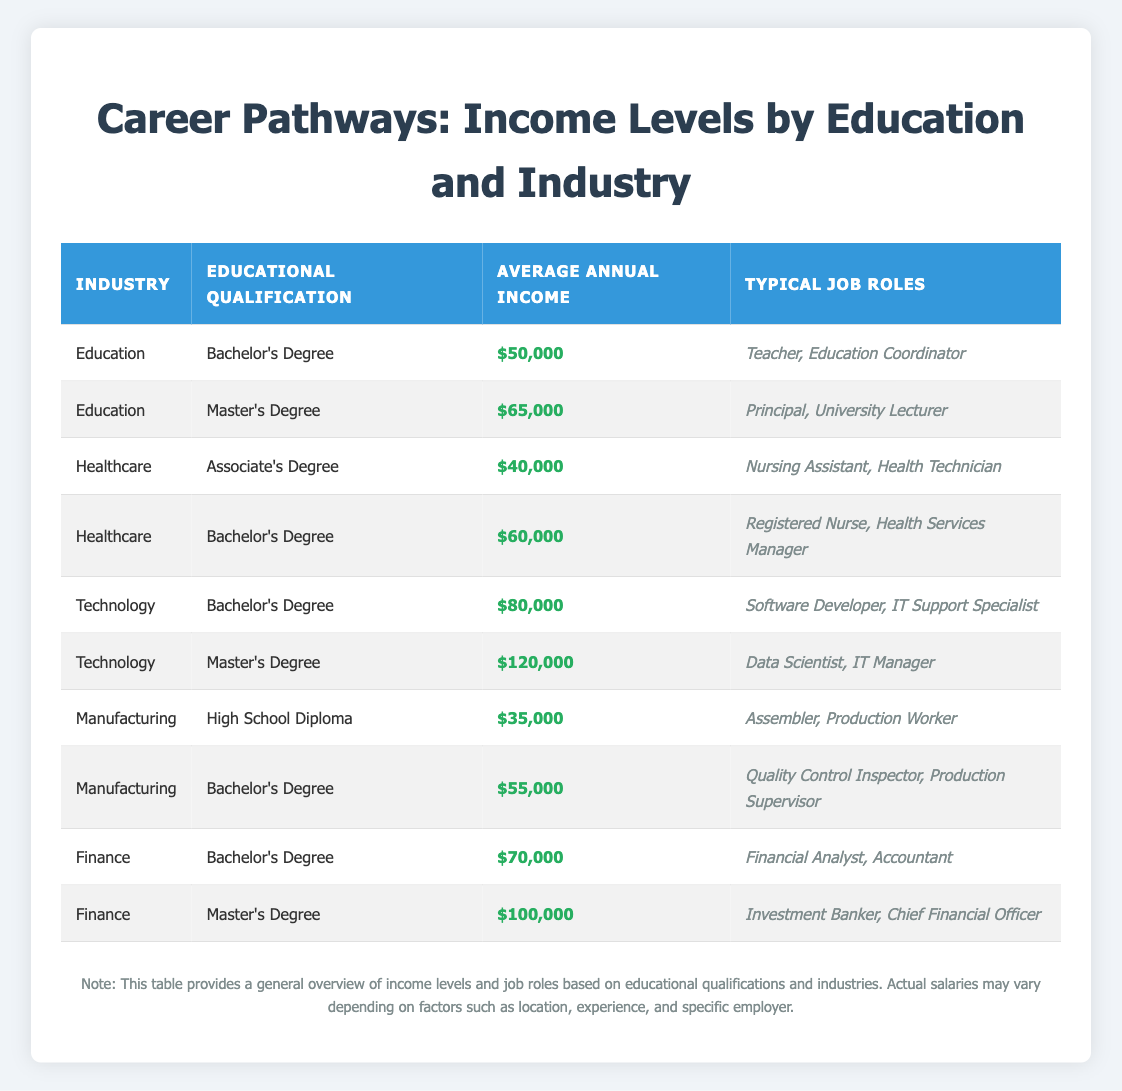What is the average annual income for a software developer? The typical job role listed under the "Technology" industry for a Bachelor's Degree is "Software Developer," which has an average annual income of $80,000 according to the table.
Answer: $80,000 Which educational qualification offers the highest average income in the Finance industry? Looking at the Finance industry, a Master's Degree average annual income of $100,000 is higher than the Bachelor's Degree income of $70,000. Therefore, the Master's Degree offers the highest income in this industry.
Answer: Master's Degree Is a Master's Degree required to be a Data Scientist? The table shows that a Data Scientist typically holds a Master's Degree in the Technology industry. Therefore, it implies that a Master's Degree is needed for this job role.
Answer: Yes What is the difference in average annual income between a Registered Nurse and a Nursing Assistant? The average income for a Registered Nurse with a Bachelor's Degree is $60,000, while for a Nursing Assistant with an Associate's Degree, it is $40,000. Thus, calculating the difference gives us $60,000 - $40,000 = $20,000.
Answer: $20,000 In which industry can you find the lowest average annual income for individuals with a High School Diploma? The Manufacturing industry lists individuals with a High School Diploma earning an average of $35,000, which is lower than other industries listed for that qualification level.
Answer: Manufacturing What average annual income is more than $70,000 in the Technology industry? Referring to the Technology industry, a Master's Degree average annual income of $120,000 is more than $70,000, along with the Bachelor's Degree average income of $80,000.
Answer: $120,000 and $80,000 How does the average annual income of a Production Supervisor compare to that of an Investment Banker? The average income for a Production Supervisor with a Bachelor's Degree in Manufacturing is $55,000, while an Investment Banker with a Master's Degree in Finance earns $100,000. Subtracting gives $100,000 - $55,000 = $45,000, showing that Investment Bankers earn more by $45,000.
Answer: $45,000 Are there more job roles listed for the Master's Degree in Education or the Bachelor's Degree in Healthcare? The Master's Degree in Education has two job roles (Principal, University Lecturer), whereas the Bachelor's Degree in Healthcare also lists two job roles (Registered Nurse, Health Services Manager). Therefore, the answer is equal.
Answer: Equal What is the typical job role associated with the highest average annual income? In the table, the highest average income listed is for a Master’s Degree in Technology, specifically for the role of Data Scientist earning $120,000.
Answer: Data Scientist 